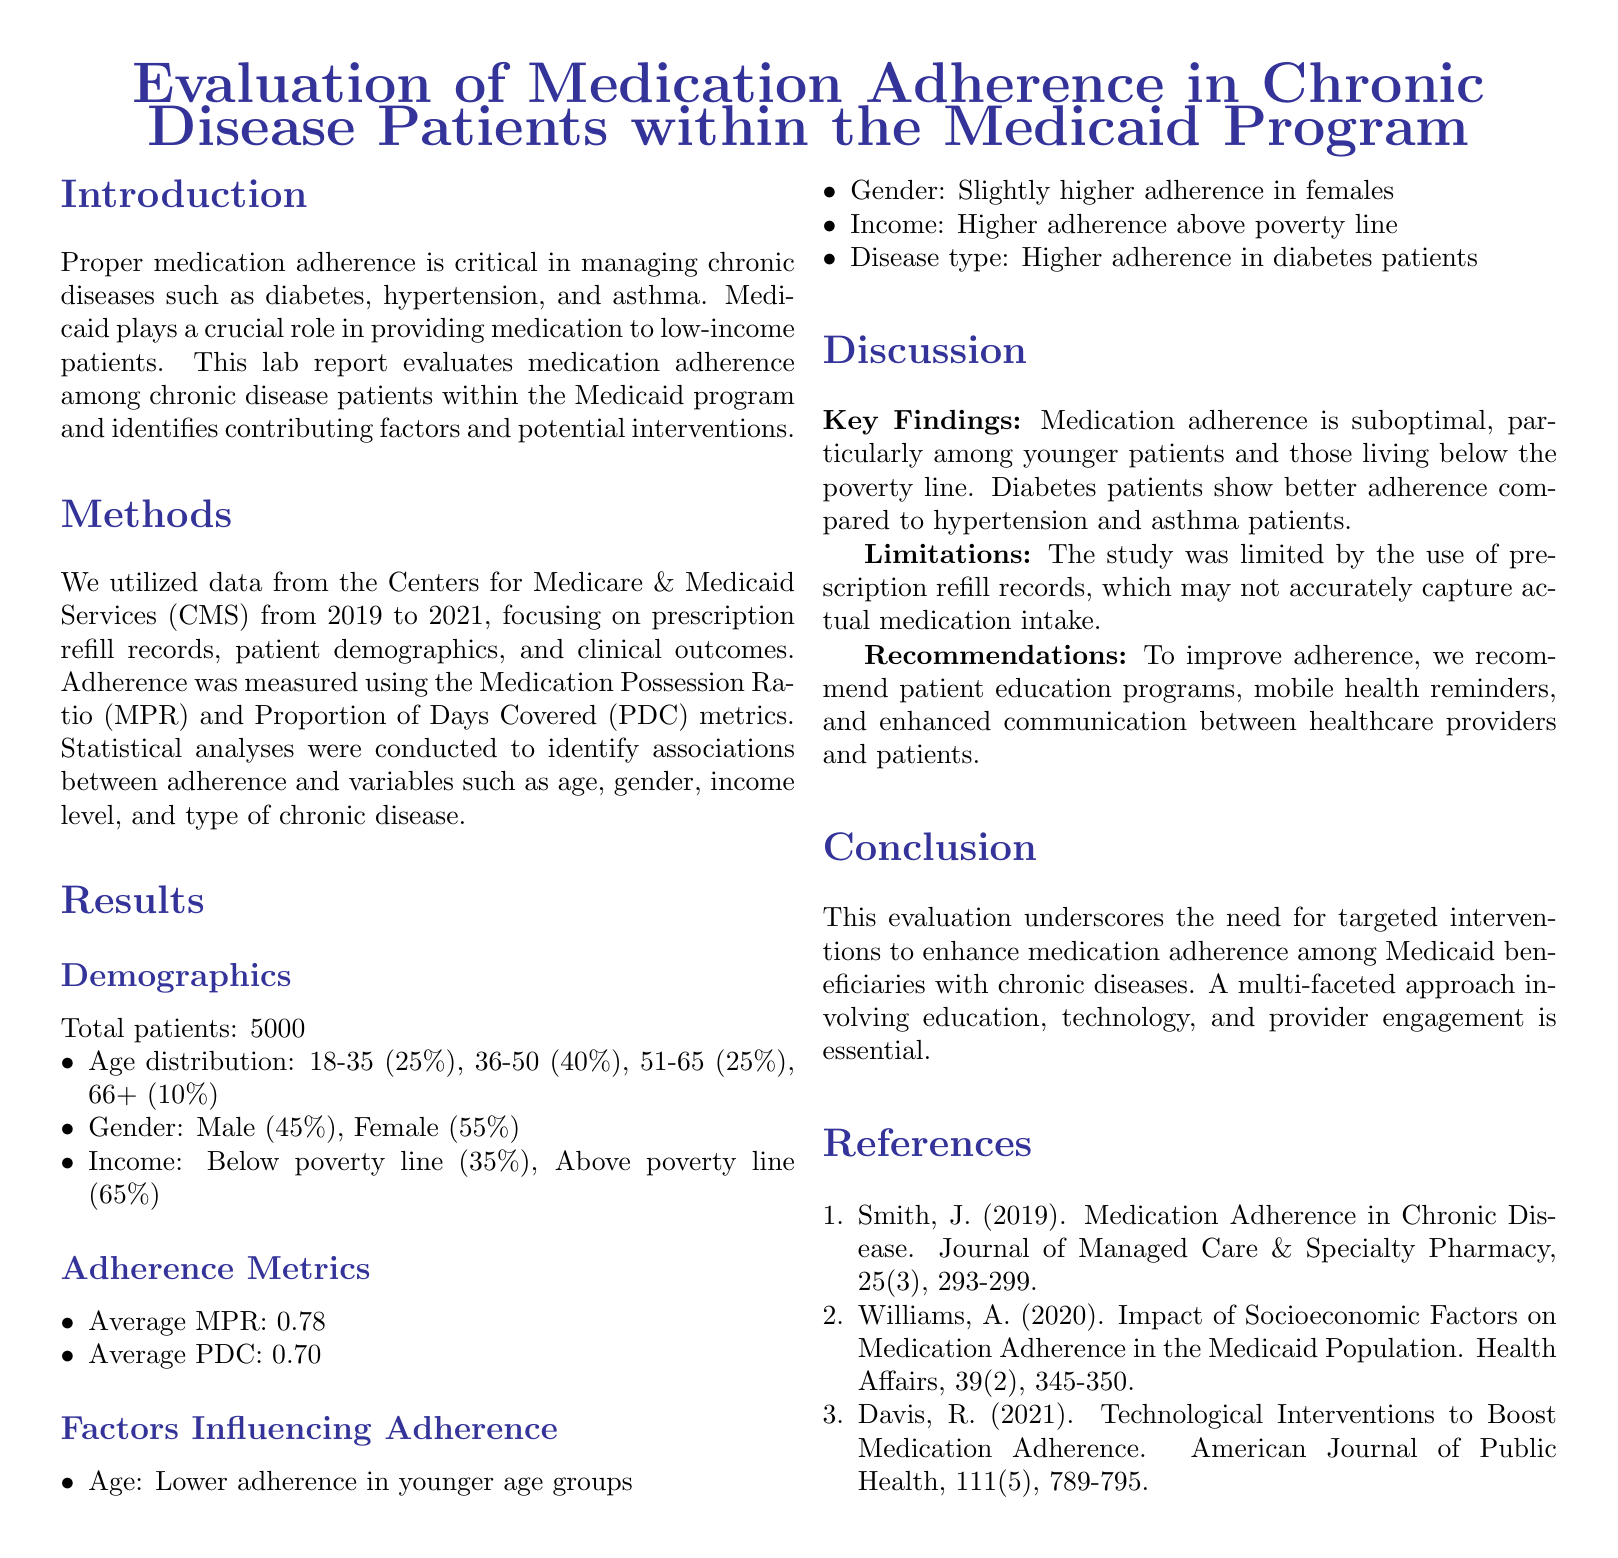what is the total number of patients studied? The report mentions a total of 5000 patients were involved in the study.
Answer: 5000 what is the average Medication Possession Ratio (MPR)? The average MPR reported in the document is used to assess medication adherence, which is stated as 0.78.
Answer: 0.78 which age group shows the lowest medication adherence? The document discusses that younger age groups exhibit lower adherence, specifically referring to those aged 18-35.
Answer: 18-35 which chronic disease patients show the highest adherence? The report highlights that diabetes patients demonstrate higher adherence than those with other chronic diseases.
Answer: diabetes what percentage of patients is below the poverty line? The provided data reveals that 35% of the patients are living below the poverty line.
Answer: 35% what method was used to measure medication adherence? The report specifies that Medication Possession Ratio (MPR) and Proportion of Days Covered (PDC) metrics were employed to measure adherence.
Answer: MPR and PDC what was one recommended intervention to improve adherence? The report suggests implementing patient education programs as one of the methods to enhance medication adherence.
Answer: patient education programs which gender has slightly higher adherence? The document indicates that females exhibited slightly higher medication adherence compared to males.
Answer: females what are the time years during which the data was collected? The data utilized in the report comes from the Centers for Medicare & Medicaid Services covering the years 2019 to 2021.
Answer: 2019 to 2021 